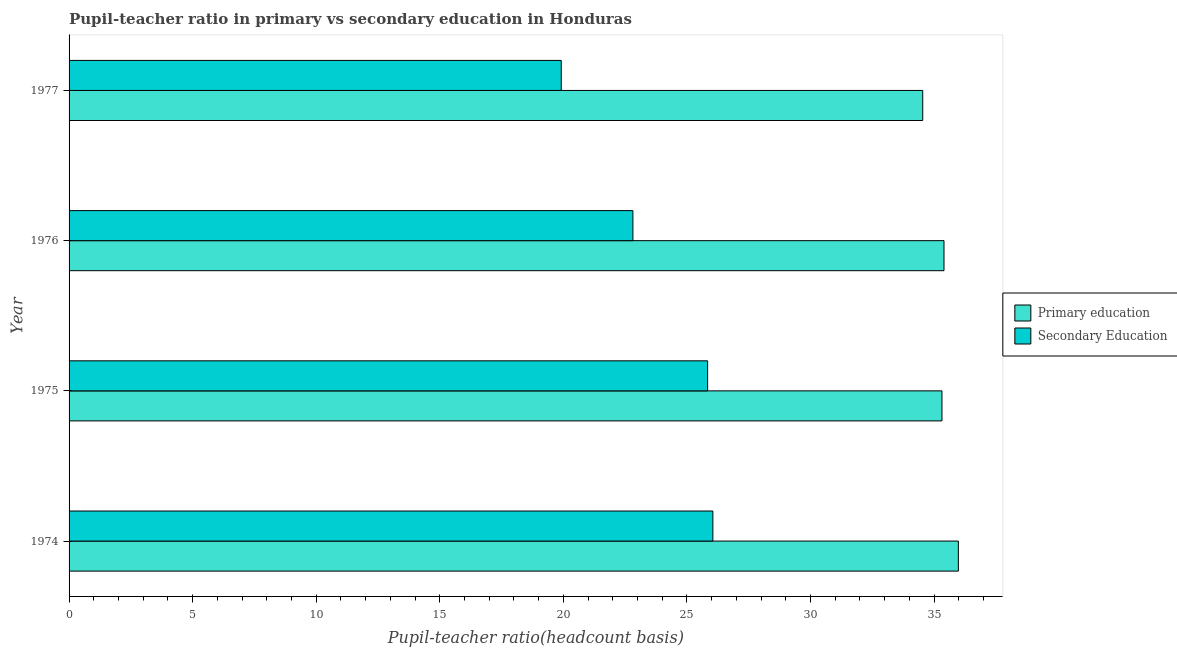Are the number of bars per tick equal to the number of legend labels?
Offer a terse response. Yes. How many bars are there on the 2nd tick from the top?
Provide a succinct answer. 2. In how many cases, is the number of bars for a given year not equal to the number of legend labels?
Make the answer very short. 0. What is the pupil teacher ratio on secondary education in 1977?
Your answer should be compact. 19.91. Across all years, what is the maximum pupil-teacher ratio in primary education?
Your answer should be very brief. 35.98. Across all years, what is the minimum pupil teacher ratio on secondary education?
Give a very brief answer. 19.91. In which year was the pupil teacher ratio on secondary education maximum?
Your response must be concise. 1974. In which year was the pupil-teacher ratio in primary education minimum?
Ensure brevity in your answer.  1977. What is the total pupil-teacher ratio in primary education in the graph?
Offer a very short reply. 141.25. What is the difference between the pupil teacher ratio on secondary education in 1975 and that in 1976?
Your answer should be very brief. 3.02. What is the difference between the pupil-teacher ratio in primary education in 1976 and the pupil teacher ratio on secondary education in 1977?
Offer a terse response. 15.49. What is the average pupil-teacher ratio in primary education per year?
Your answer should be compact. 35.31. In the year 1977, what is the difference between the pupil teacher ratio on secondary education and pupil-teacher ratio in primary education?
Your answer should be compact. -14.63. What is the ratio of the pupil teacher ratio on secondary education in 1976 to that in 1977?
Keep it short and to the point. 1.15. Is the pupil-teacher ratio in primary education in 1975 less than that in 1976?
Provide a succinct answer. Yes. What is the difference between the highest and the second highest pupil-teacher ratio in primary education?
Keep it short and to the point. 0.58. What is the difference between the highest and the lowest pupil teacher ratio on secondary education?
Your answer should be very brief. 6.13. Is the sum of the pupil-teacher ratio in primary education in 1975 and 1976 greater than the maximum pupil teacher ratio on secondary education across all years?
Give a very brief answer. Yes. What does the 2nd bar from the top in 1976 represents?
Give a very brief answer. Primary education. What does the 1st bar from the bottom in 1976 represents?
Ensure brevity in your answer.  Primary education. Are all the bars in the graph horizontal?
Ensure brevity in your answer.  Yes. How many years are there in the graph?
Your answer should be very brief. 4. What is the difference between two consecutive major ticks on the X-axis?
Offer a very short reply. 5. Are the values on the major ticks of X-axis written in scientific E-notation?
Your response must be concise. No. Does the graph contain any zero values?
Keep it short and to the point. No. Does the graph contain grids?
Offer a very short reply. No. Where does the legend appear in the graph?
Keep it short and to the point. Center right. How many legend labels are there?
Ensure brevity in your answer.  2. What is the title of the graph?
Give a very brief answer. Pupil-teacher ratio in primary vs secondary education in Honduras. What is the label or title of the X-axis?
Give a very brief answer. Pupil-teacher ratio(headcount basis). What is the Pupil-teacher ratio(headcount basis) in Primary education in 1974?
Make the answer very short. 35.98. What is the Pupil-teacher ratio(headcount basis) of Secondary Education in 1974?
Your response must be concise. 26.05. What is the Pupil-teacher ratio(headcount basis) of Primary education in 1975?
Offer a very short reply. 35.32. What is the Pupil-teacher ratio(headcount basis) in Secondary Education in 1975?
Offer a very short reply. 25.84. What is the Pupil-teacher ratio(headcount basis) in Primary education in 1976?
Provide a succinct answer. 35.4. What is the Pupil-teacher ratio(headcount basis) of Secondary Education in 1976?
Ensure brevity in your answer.  22.81. What is the Pupil-teacher ratio(headcount basis) of Primary education in 1977?
Your answer should be compact. 34.54. What is the Pupil-teacher ratio(headcount basis) in Secondary Education in 1977?
Your response must be concise. 19.91. Across all years, what is the maximum Pupil-teacher ratio(headcount basis) in Primary education?
Offer a terse response. 35.98. Across all years, what is the maximum Pupil-teacher ratio(headcount basis) of Secondary Education?
Ensure brevity in your answer.  26.05. Across all years, what is the minimum Pupil-teacher ratio(headcount basis) in Primary education?
Make the answer very short. 34.54. Across all years, what is the minimum Pupil-teacher ratio(headcount basis) in Secondary Education?
Offer a very short reply. 19.91. What is the total Pupil-teacher ratio(headcount basis) of Primary education in the graph?
Your answer should be compact. 141.25. What is the total Pupil-teacher ratio(headcount basis) of Secondary Education in the graph?
Your answer should be compact. 94.62. What is the difference between the Pupil-teacher ratio(headcount basis) of Primary education in 1974 and that in 1975?
Make the answer very short. 0.66. What is the difference between the Pupil-teacher ratio(headcount basis) of Secondary Education in 1974 and that in 1975?
Keep it short and to the point. 0.21. What is the difference between the Pupil-teacher ratio(headcount basis) in Primary education in 1974 and that in 1976?
Your response must be concise. 0.58. What is the difference between the Pupil-teacher ratio(headcount basis) of Secondary Education in 1974 and that in 1976?
Make the answer very short. 3.24. What is the difference between the Pupil-teacher ratio(headcount basis) of Primary education in 1974 and that in 1977?
Provide a succinct answer. 1.44. What is the difference between the Pupil-teacher ratio(headcount basis) in Secondary Education in 1974 and that in 1977?
Make the answer very short. 6.13. What is the difference between the Pupil-teacher ratio(headcount basis) of Primary education in 1975 and that in 1976?
Your response must be concise. -0.08. What is the difference between the Pupil-teacher ratio(headcount basis) in Secondary Education in 1975 and that in 1976?
Make the answer very short. 3.02. What is the difference between the Pupil-teacher ratio(headcount basis) of Primary education in 1975 and that in 1977?
Keep it short and to the point. 0.78. What is the difference between the Pupil-teacher ratio(headcount basis) in Secondary Education in 1975 and that in 1977?
Keep it short and to the point. 5.92. What is the difference between the Pupil-teacher ratio(headcount basis) of Primary education in 1976 and that in 1977?
Offer a terse response. 0.86. What is the difference between the Pupil-teacher ratio(headcount basis) of Secondary Education in 1976 and that in 1977?
Provide a short and direct response. 2.9. What is the difference between the Pupil-teacher ratio(headcount basis) in Primary education in 1974 and the Pupil-teacher ratio(headcount basis) in Secondary Education in 1975?
Ensure brevity in your answer.  10.15. What is the difference between the Pupil-teacher ratio(headcount basis) of Primary education in 1974 and the Pupil-teacher ratio(headcount basis) of Secondary Education in 1976?
Offer a very short reply. 13.17. What is the difference between the Pupil-teacher ratio(headcount basis) of Primary education in 1974 and the Pupil-teacher ratio(headcount basis) of Secondary Education in 1977?
Your answer should be compact. 16.07. What is the difference between the Pupil-teacher ratio(headcount basis) in Primary education in 1975 and the Pupil-teacher ratio(headcount basis) in Secondary Education in 1976?
Make the answer very short. 12.51. What is the difference between the Pupil-teacher ratio(headcount basis) of Primary education in 1975 and the Pupil-teacher ratio(headcount basis) of Secondary Education in 1977?
Offer a terse response. 15.4. What is the difference between the Pupil-teacher ratio(headcount basis) of Primary education in 1976 and the Pupil-teacher ratio(headcount basis) of Secondary Education in 1977?
Offer a very short reply. 15.49. What is the average Pupil-teacher ratio(headcount basis) in Primary education per year?
Your answer should be compact. 35.31. What is the average Pupil-teacher ratio(headcount basis) in Secondary Education per year?
Give a very brief answer. 23.65. In the year 1974, what is the difference between the Pupil-teacher ratio(headcount basis) of Primary education and Pupil-teacher ratio(headcount basis) of Secondary Education?
Keep it short and to the point. 9.93. In the year 1975, what is the difference between the Pupil-teacher ratio(headcount basis) of Primary education and Pupil-teacher ratio(headcount basis) of Secondary Education?
Provide a succinct answer. 9.48. In the year 1976, what is the difference between the Pupil-teacher ratio(headcount basis) in Primary education and Pupil-teacher ratio(headcount basis) in Secondary Education?
Make the answer very short. 12.59. In the year 1977, what is the difference between the Pupil-teacher ratio(headcount basis) of Primary education and Pupil-teacher ratio(headcount basis) of Secondary Education?
Give a very brief answer. 14.63. What is the ratio of the Pupil-teacher ratio(headcount basis) in Primary education in 1974 to that in 1975?
Give a very brief answer. 1.02. What is the ratio of the Pupil-teacher ratio(headcount basis) of Secondary Education in 1974 to that in 1975?
Make the answer very short. 1.01. What is the ratio of the Pupil-teacher ratio(headcount basis) in Primary education in 1974 to that in 1976?
Make the answer very short. 1.02. What is the ratio of the Pupil-teacher ratio(headcount basis) of Secondary Education in 1974 to that in 1976?
Your answer should be compact. 1.14. What is the ratio of the Pupil-teacher ratio(headcount basis) in Primary education in 1974 to that in 1977?
Your answer should be very brief. 1.04. What is the ratio of the Pupil-teacher ratio(headcount basis) of Secondary Education in 1974 to that in 1977?
Your answer should be very brief. 1.31. What is the ratio of the Pupil-teacher ratio(headcount basis) in Secondary Education in 1975 to that in 1976?
Offer a very short reply. 1.13. What is the ratio of the Pupil-teacher ratio(headcount basis) in Primary education in 1975 to that in 1977?
Your answer should be compact. 1.02. What is the ratio of the Pupil-teacher ratio(headcount basis) of Secondary Education in 1975 to that in 1977?
Ensure brevity in your answer.  1.3. What is the ratio of the Pupil-teacher ratio(headcount basis) of Primary education in 1976 to that in 1977?
Provide a succinct answer. 1.02. What is the ratio of the Pupil-teacher ratio(headcount basis) of Secondary Education in 1976 to that in 1977?
Keep it short and to the point. 1.15. What is the difference between the highest and the second highest Pupil-teacher ratio(headcount basis) of Primary education?
Keep it short and to the point. 0.58. What is the difference between the highest and the second highest Pupil-teacher ratio(headcount basis) of Secondary Education?
Offer a very short reply. 0.21. What is the difference between the highest and the lowest Pupil-teacher ratio(headcount basis) of Primary education?
Your answer should be very brief. 1.44. What is the difference between the highest and the lowest Pupil-teacher ratio(headcount basis) of Secondary Education?
Your answer should be compact. 6.13. 